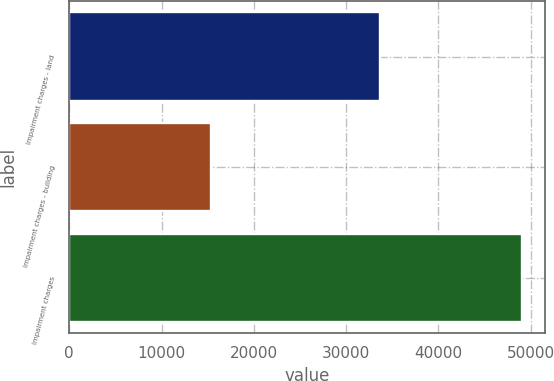Convert chart to OTSL. <chart><loc_0><loc_0><loc_500><loc_500><bar_chart><fcel>Impairment charges - land<fcel>Impairment charges - building<fcel>Impairment charges<nl><fcel>33700<fcel>15406<fcel>49106<nl></chart> 